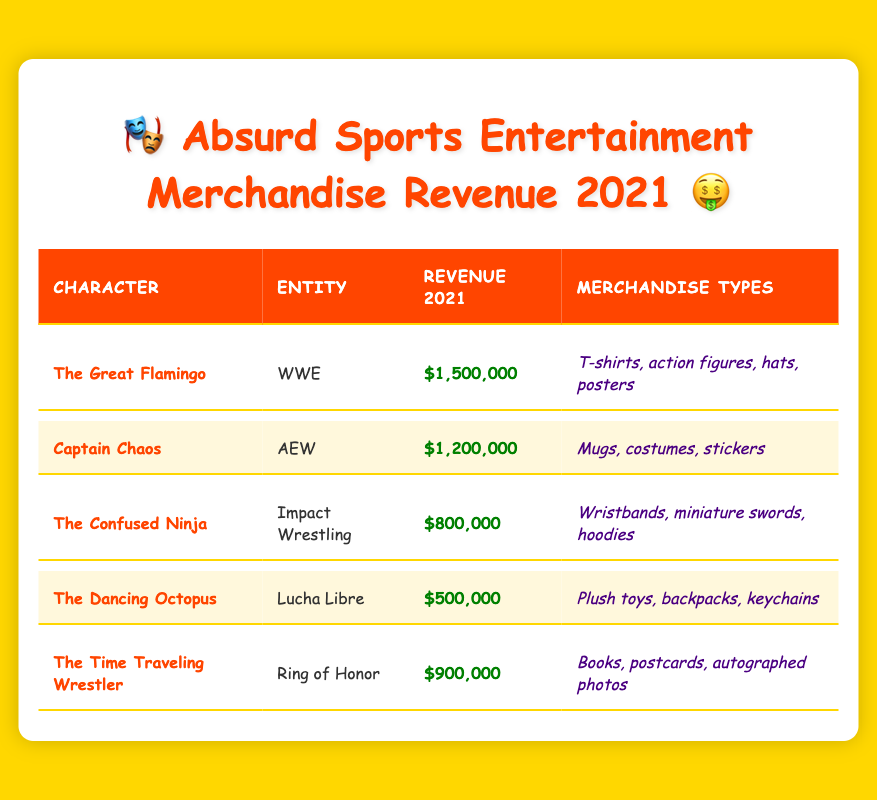What character generated the highest merchandise revenue in 2021? By examining the revenue column in the table, we see that The Great Flamingo from WWE has the highest revenue of $1,500,000 when compared to the other characters listed.
Answer: The Great Flamingo What was the total revenue generated from merchandise by Captain Chaos and The Confused Ninja in 2021? The revenue for Captain Chaos is $1,200,000, and for The Confused Ninja it is $800,000. Adding these two gives us $1,200,000 + $800,000 = $2,000,000 as the total revenue.
Answer: $2,000,000 Did The Dancing Octopus generate more revenue than The Time Traveling Wrestler in 2021? The revenue for The Dancing Octopus is $500,000 while The Time Traveling Wrestler generated $900,000. Since $500,000 is less than $900,000, the answer is no.
Answer: No Which merchandise type was sold for The Confused Ninja? Looking at the merchandise types listed for The Confused Ninja, they include wristbands, miniature swords, and hoodies. These are explicitly mentioned in the merchandise column for that character.
Answer: Wristbands, miniature swords, hoodies What is the average revenue generated from merchandise by the five characters? The revenues for each character are $1,500,000, $1,200,000, $800,000, $500,000, and $900,000. Adding these values gives us $5,900,000. To find the average, we divide by the number of characters, which is 5, resulting in an average revenue of $5,900,000 / 5 = $1,180,000.
Answer: $1,180,000 Which character had the least amount of merchandise revenue? By checking the revenue column, we see that The Dancing Octopus generated the least revenue with $500,000 compared to the other characters listed.
Answer: The Dancing Octopus How much more revenue did The Great Flamingo generate than The Time Traveling Wrestler? The revenue for The Great Flamingo is $1,500,000 and for The Time Traveling Wrestler it is $900,000. To find the difference, we subtract: $1,500,000 - $900,000 = $600,000.
Answer: $600,000 Which characters had a revenue of $800,000 or more in 2021? The characters with revenue of $800,000 or more include The Great Flamingo ($1,500,000), Captain Chaos ($1,200,000), The Confused Ninja ($800,000), and The Time Traveling Wrestler ($900,000). Looking through the revenue column confirms this list.
Answer: The Great Flamingo, Captain Chaos, The Confused Ninja, The Time Traveling Wrestler 